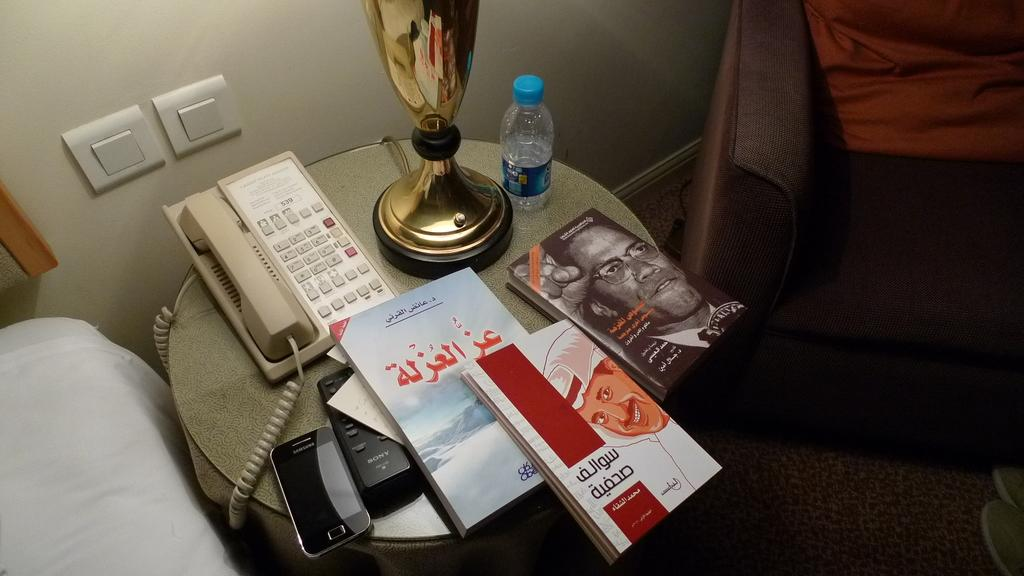<image>
Provide a brief description of the given image. A Samsung phone is on the table next to a remote. 